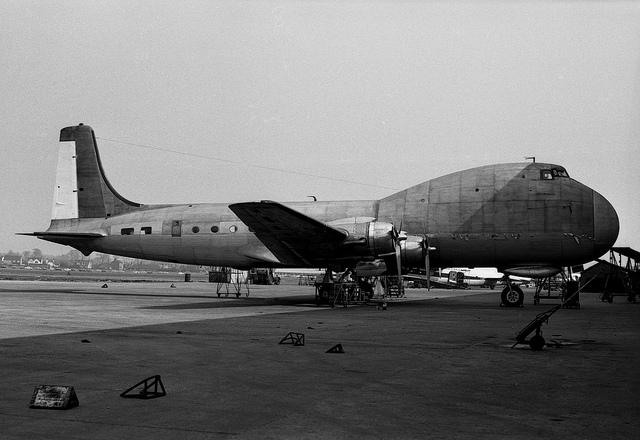What color is the plane?
Keep it brief. Gray. What is the narrowest part of the plane?
Be succinct. Tail. How many airplanes do you see?
Be succinct. 1. Is this airplane parked?
Write a very short answer. Yes. Is this a new plane?
Be succinct. No. Is this airport in the city or country?
Be succinct. City. 